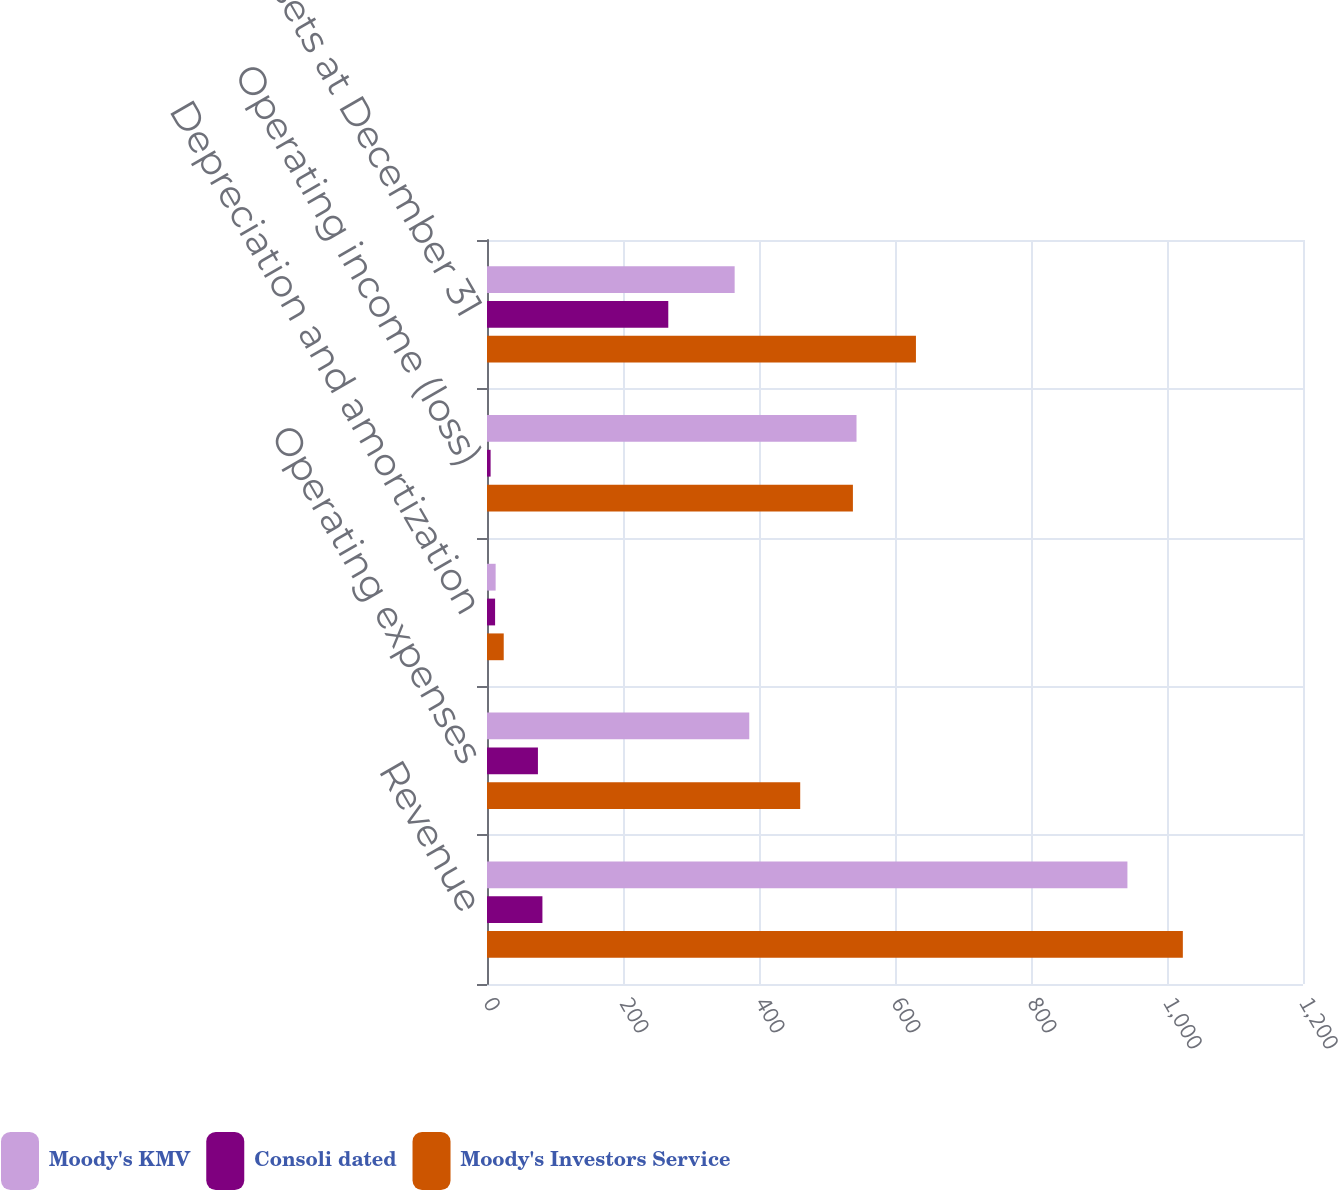Convert chart to OTSL. <chart><loc_0><loc_0><loc_500><loc_500><stacked_bar_chart><ecel><fcel>Revenue<fcel>Operating expenses<fcel>Depreciation and amortization<fcel>Operating income (loss)<fcel>Total assets at December 31<nl><fcel>Moody's KMV<fcel>941.8<fcel>385.7<fcel>12.7<fcel>543.4<fcel>364.2<nl><fcel>Consoli dated<fcel>81.5<fcel>74.9<fcel>11.9<fcel>5.3<fcel>266.6<nl><fcel>Moody's Investors Service<fcel>1023.3<fcel>460.6<fcel>24.6<fcel>538.1<fcel>630.8<nl></chart> 